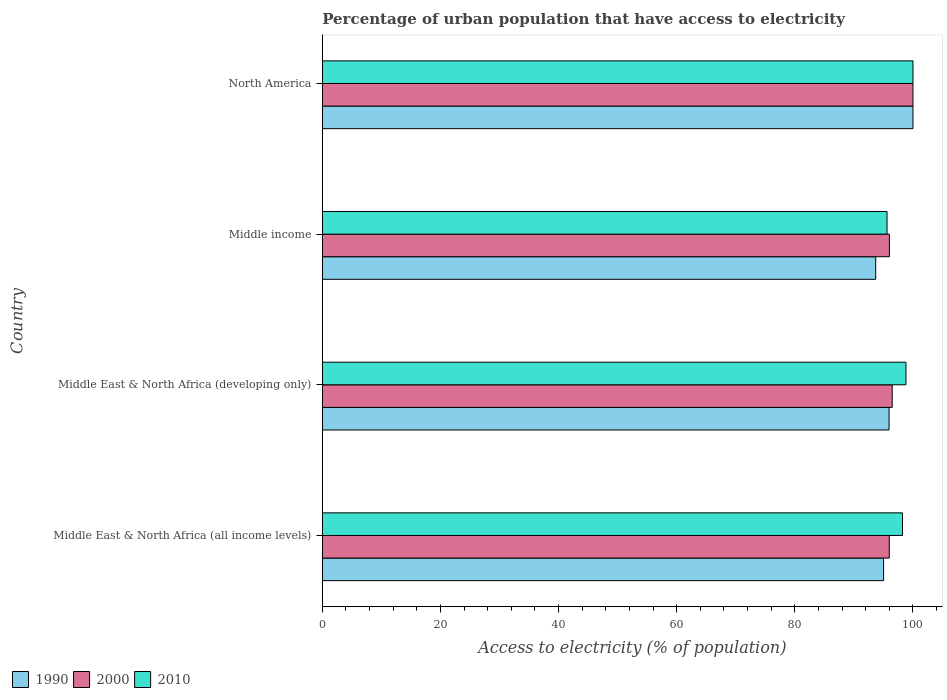How many different coloured bars are there?
Keep it short and to the point. 3. What is the label of the 3rd group of bars from the top?
Your answer should be compact. Middle East & North Africa (developing only). What is the percentage of urban population that have access to electricity in 1990 in Middle East & North Africa (developing only)?
Provide a succinct answer. 95.95. Across all countries, what is the maximum percentage of urban population that have access to electricity in 1990?
Your answer should be compact. 100. Across all countries, what is the minimum percentage of urban population that have access to electricity in 2000?
Offer a very short reply. 95.99. In which country was the percentage of urban population that have access to electricity in 2000 maximum?
Give a very brief answer. North America. In which country was the percentage of urban population that have access to electricity in 1990 minimum?
Your response must be concise. Middle income. What is the total percentage of urban population that have access to electricity in 2000 in the graph?
Provide a succinct answer. 388.48. What is the difference between the percentage of urban population that have access to electricity in 2000 in Middle East & North Africa (developing only) and that in Middle income?
Your answer should be very brief. 0.47. What is the difference between the percentage of urban population that have access to electricity in 2000 in Middle income and the percentage of urban population that have access to electricity in 2010 in Middle East & North Africa (all income levels)?
Make the answer very short. -2.22. What is the average percentage of urban population that have access to electricity in 1990 per country?
Provide a short and direct response. 96.17. What is the difference between the percentage of urban population that have access to electricity in 1990 and percentage of urban population that have access to electricity in 2010 in Middle East & North Africa (developing only)?
Your answer should be very brief. -2.86. In how many countries, is the percentage of urban population that have access to electricity in 2000 greater than 56 %?
Offer a very short reply. 4. What is the ratio of the percentage of urban population that have access to electricity in 2010 in Middle East & North Africa (developing only) to that in Middle income?
Keep it short and to the point. 1.03. Is the percentage of urban population that have access to electricity in 1990 in Middle income less than that in North America?
Your response must be concise. Yes. Is the difference between the percentage of urban population that have access to electricity in 1990 in Middle East & North Africa (all income levels) and North America greater than the difference between the percentage of urban population that have access to electricity in 2010 in Middle East & North Africa (all income levels) and North America?
Offer a terse response. No. What is the difference between the highest and the second highest percentage of urban population that have access to electricity in 1990?
Keep it short and to the point. 4.05. What is the difference between the highest and the lowest percentage of urban population that have access to electricity in 2000?
Ensure brevity in your answer.  4.01. In how many countries, is the percentage of urban population that have access to electricity in 2010 greater than the average percentage of urban population that have access to electricity in 2010 taken over all countries?
Provide a succinct answer. 3. How many bars are there?
Your answer should be compact. 12. What is the difference between two consecutive major ticks on the X-axis?
Provide a short and direct response. 20. Does the graph contain any zero values?
Your answer should be compact. No. Where does the legend appear in the graph?
Your answer should be very brief. Bottom left. What is the title of the graph?
Offer a very short reply. Percentage of urban population that have access to electricity. What is the label or title of the X-axis?
Your response must be concise. Access to electricity (% of population). What is the label or title of the Y-axis?
Make the answer very short. Country. What is the Access to electricity (% of population) in 1990 in Middle East & North Africa (all income levels)?
Offer a very short reply. 95.03. What is the Access to electricity (% of population) in 2000 in Middle East & North Africa (all income levels)?
Provide a short and direct response. 95.99. What is the Access to electricity (% of population) of 2010 in Middle East & North Africa (all income levels)?
Keep it short and to the point. 98.23. What is the Access to electricity (% of population) of 1990 in Middle East & North Africa (developing only)?
Your answer should be very brief. 95.95. What is the Access to electricity (% of population) in 2000 in Middle East & North Africa (developing only)?
Offer a terse response. 96.48. What is the Access to electricity (% of population) of 2010 in Middle East & North Africa (developing only)?
Your response must be concise. 98.82. What is the Access to electricity (% of population) in 1990 in Middle income?
Provide a succinct answer. 93.69. What is the Access to electricity (% of population) in 2000 in Middle income?
Give a very brief answer. 96.01. What is the Access to electricity (% of population) of 2010 in Middle income?
Keep it short and to the point. 95.61. What is the Access to electricity (% of population) of 1990 in North America?
Make the answer very short. 100. What is the Access to electricity (% of population) in 2000 in North America?
Provide a short and direct response. 100. Across all countries, what is the maximum Access to electricity (% of population) in 1990?
Your answer should be compact. 100. Across all countries, what is the maximum Access to electricity (% of population) of 2000?
Offer a very short reply. 100. Across all countries, what is the minimum Access to electricity (% of population) in 1990?
Your answer should be compact. 93.69. Across all countries, what is the minimum Access to electricity (% of population) of 2000?
Ensure brevity in your answer.  95.99. Across all countries, what is the minimum Access to electricity (% of population) of 2010?
Your answer should be very brief. 95.61. What is the total Access to electricity (% of population) of 1990 in the graph?
Your response must be concise. 384.67. What is the total Access to electricity (% of population) in 2000 in the graph?
Your response must be concise. 388.48. What is the total Access to electricity (% of population) in 2010 in the graph?
Your answer should be very brief. 392.65. What is the difference between the Access to electricity (% of population) in 1990 in Middle East & North Africa (all income levels) and that in Middle East & North Africa (developing only)?
Your answer should be very brief. -0.93. What is the difference between the Access to electricity (% of population) of 2000 in Middle East & North Africa (all income levels) and that in Middle East & North Africa (developing only)?
Give a very brief answer. -0.49. What is the difference between the Access to electricity (% of population) in 2010 in Middle East & North Africa (all income levels) and that in Middle East & North Africa (developing only)?
Your response must be concise. -0.59. What is the difference between the Access to electricity (% of population) in 1990 in Middle East & North Africa (all income levels) and that in Middle income?
Offer a very short reply. 1.34. What is the difference between the Access to electricity (% of population) of 2000 in Middle East & North Africa (all income levels) and that in Middle income?
Your response must be concise. -0.02. What is the difference between the Access to electricity (% of population) of 2010 in Middle East & North Africa (all income levels) and that in Middle income?
Ensure brevity in your answer.  2.62. What is the difference between the Access to electricity (% of population) of 1990 in Middle East & North Africa (all income levels) and that in North America?
Offer a very short reply. -4.97. What is the difference between the Access to electricity (% of population) of 2000 in Middle East & North Africa (all income levels) and that in North America?
Your answer should be very brief. -4.01. What is the difference between the Access to electricity (% of population) in 2010 in Middle East & North Africa (all income levels) and that in North America?
Provide a succinct answer. -1.77. What is the difference between the Access to electricity (% of population) in 1990 in Middle East & North Africa (developing only) and that in Middle income?
Provide a short and direct response. 2.26. What is the difference between the Access to electricity (% of population) in 2000 in Middle East & North Africa (developing only) and that in Middle income?
Give a very brief answer. 0.47. What is the difference between the Access to electricity (% of population) in 2010 in Middle East & North Africa (developing only) and that in Middle income?
Provide a short and direct response. 3.21. What is the difference between the Access to electricity (% of population) of 1990 in Middle East & North Africa (developing only) and that in North America?
Offer a terse response. -4.05. What is the difference between the Access to electricity (% of population) in 2000 in Middle East & North Africa (developing only) and that in North America?
Keep it short and to the point. -3.52. What is the difference between the Access to electricity (% of population) in 2010 in Middle East & North Africa (developing only) and that in North America?
Keep it short and to the point. -1.18. What is the difference between the Access to electricity (% of population) of 1990 in Middle income and that in North America?
Offer a terse response. -6.31. What is the difference between the Access to electricity (% of population) of 2000 in Middle income and that in North America?
Give a very brief answer. -3.99. What is the difference between the Access to electricity (% of population) of 2010 in Middle income and that in North America?
Provide a succinct answer. -4.39. What is the difference between the Access to electricity (% of population) in 1990 in Middle East & North Africa (all income levels) and the Access to electricity (% of population) in 2000 in Middle East & North Africa (developing only)?
Make the answer very short. -1.46. What is the difference between the Access to electricity (% of population) in 1990 in Middle East & North Africa (all income levels) and the Access to electricity (% of population) in 2010 in Middle East & North Africa (developing only)?
Your answer should be very brief. -3.79. What is the difference between the Access to electricity (% of population) in 2000 in Middle East & North Africa (all income levels) and the Access to electricity (% of population) in 2010 in Middle East & North Africa (developing only)?
Provide a succinct answer. -2.83. What is the difference between the Access to electricity (% of population) of 1990 in Middle East & North Africa (all income levels) and the Access to electricity (% of population) of 2000 in Middle income?
Your answer should be very brief. -0.98. What is the difference between the Access to electricity (% of population) of 1990 in Middle East & North Africa (all income levels) and the Access to electricity (% of population) of 2010 in Middle income?
Your answer should be compact. -0.58. What is the difference between the Access to electricity (% of population) in 2000 in Middle East & North Africa (all income levels) and the Access to electricity (% of population) in 2010 in Middle income?
Give a very brief answer. 0.38. What is the difference between the Access to electricity (% of population) in 1990 in Middle East & North Africa (all income levels) and the Access to electricity (% of population) in 2000 in North America?
Provide a succinct answer. -4.97. What is the difference between the Access to electricity (% of population) in 1990 in Middle East & North Africa (all income levels) and the Access to electricity (% of population) in 2010 in North America?
Your answer should be compact. -4.97. What is the difference between the Access to electricity (% of population) of 2000 in Middle East & North Africa (all income levels) and the Access to electricity (% of population) of 2010 in North America?
Provide a succinct answer. -4.01. What is the difference between the Access to electricity (% of population) of 1990 in Middle East & North Africa (developing only) and the Access to electricity (% of population) of 2000 in Middle income?
Your response must be concise. -0.06. What is the difference between the Access to electricity (% of population) of 1990 in Middle East & North Africa (developing only) and the Access to electricity (% of population) of 2010 in Middle income?
Make the answer very short. 0.34. What is the difference between the Access to electricity (% of population) of 2000 in Middle East & North Africa (developing only) and the Access to electricity (% of population) of 2010 in Middle income?
Your answer should be very brief. 0.87. What is the difference between the Access to electricity (% of population) of 1990 in Middle East & North Africa (developing only) and the Access to electricity (% of population) of 2000 in North America?
Keep it short and to the point. -4.05. What is the difference between the Access to electricity (% of population) in 1990 in Middle East & North Africa (developing only) and the Access to electricity (% of population) in 2010 in North America?
Your response must be concise. -4.05. What is the difference between the Access to electricity (% of population) of 2000 in Middle East & North Africa (developing only) and the Access to electricity (% of population) of 2010 in North America?
Make the answer very short. -3.52. What is the difference between the Access to electricity (% of population) in 1990 in Middle income and the Access to electricity (% of population) in 2000 in North America?
Make the answer very short. -6.31. What is the difference between the Access to electricity (% of population) of 1990 in Middle income and the Access to electricity (% of population) of 2010 in North America?
Give a very brief answer. -6.31. What is the difference between the Access to electricity (% of population) in 2000 in Middle income and the Access to electricity (% of population) in 2010 in North America?
Make the answer very short. -3.99. What is the average Access to electricity (% of population) of 1990 per country?
Keep it short and to the point. 96.17. What is the average Access to electricity (% of population) of 2000 per country?
Your answer should be compact. 97.12. What is the average Access to electricity (% of population) in 2010 per country?
Your answer should be compact. 98.16. What is the difference between the Access to electricity (% of population) of 1990 and Access to electricity (% of population) of 2000 in Middle East & North Africa (all income levels)?
Your answer should be compact. -0.96. What is the difference between the Access to electricity (% of population) of 1990 and Access to electricity (% of population) of 2010 in Middle East & North Africa (all income levels)?
Your response must be concise. -3.2. What is the difference between the Access to electricity (% of population) in 2000 and Access to electricity (% of population) in 2010 in Middle East & North Africa (all income levels)?
Make the answer very short. -2.24. What is the difference between the Access to electricity (% of population) of 1990 and Access to electricity (% of population) of 2000 in Middle East & North Africa (developing only)?
Provide a succinct answer. -0.53. What is the difference between the Access to electricity (% of population) of 1990 and Access to electricity (% of population) of 2010 in Middle East & North Africa (developing only)?
Offer a very short reply. -2.86. What is the difference between the Access to electricity (% of population) in 2000 and Access to electricity (% of population) in 2010 in Middle East & North Africa (developing only)?
Offer a very short reply. -2.33. What is the difference between the Access to electricity (% of population) of 1990 and Access to electricity (% of population) of 2000 in Middle income?
Provide a succinct answer. -2.32. What is the difference between the Access to electricity (% of population) of 1990 and Access to electricity (% of population) of 2010 in Middle income?
Offer a terse response. -1.92. What is the difference between the Access to electricity (% of population) in 2000 and Access to electricity (% of population) in 2010 in Middle income?
Provide a succinct answer. 0.4. What is the difference between the Access to electricity (% of population) in 1990 and Access to electricity (% of population) in 2010 in North America?
Make the answer very short. 0. What is the difference between the Access to electricity (% of population) in 2000 and Access to electricity (% of population) in 2010 in North America?
Provide a succinct answer. 0. What is the ratio of the Access to electricity (% of population) of 1990 in Middle East & North Africa (all income levels) to that in Middle East & North Africa (developing only)?
Offer a terse response. 0.99. What is the ratio of the Access to electricity (% of population) of 1990 in Middle East & North Africa (all income levels) to that in Middle income?
Ensure brevity in your answer.  1.01. What is the ratio of the Access to electricity (% of population) in 2000 in Middle East & North Africa (all income levels) to that in Middle income?
Keep it short and to the point. 1. What is the ratio of the Access to electricity (% of population) in 2010 in Middle East & North Africa (all income levels) to that in Middle income?
Offer a very short reply. 1.03. What is the ratio of the Access to electricity (% of population) in 1990 in Middle East & North Africa (all income levels) to that in North America?
Keep it short and to the point. 0.95. What is the ratio of the Access to electricity (% of population) of 2000 in Middle East & North Africa (all income levels) to that in North America?
Your response must be concise. 0.96. What is the ratio of the Access to electricity (% of population) of 2010 in Middle East & North Africa (all income levels) to that in North America?
Offer a terse response. 0.98. What is the ratio of the Access to electricity (% of population) in 1990 in Middle East & North Africa (developing only) to that in Middle income?
Ensure brevity in your answer.  1.02. What is the ratio of the Access to electricity (% of population) in 2000 in Middle East & North Africa (developing only) to that in Middle income?
Your response must be concise. 1. What is the ratio of the Access to electricity (% of population) of 2010 in Middle East & North Africa (developing only) to that in Middle income?
Ensure brevity in your answer.  1.03. What is the ratio of the Access to electricity (% of population) in 1990 in Middle East & North Africa (developing only) to that in North America?
Your answer should be very brief. 0.96. What is the ratio of the Access to electricity (% of population) in 2000 in Middle East & North Africa (developing only) to that in North America?
Offer a very short reply. 0.96. What is the ratio of the Access to electricity (% of population) of 1990 in Middle income to that in North America?
Offer a very short reply. 0.94. What is the ratio of the Access to electricity (% of population) of 2000 in Middle income to that in North America?
Your answer should be very brief. 0.96. What is the ratio of the Access to electricity (% of population) of 2010 in Middle income to that in North America?
Ensure brevity in your answer.  0.96. What is the difference between the highest and the second highest Access to electricity (% of population) of 1990?
Ensure brevity in your answer.  4.05. What is the difference between the highest and the second highest Access to electricity (% of population) of 2000?
Offer a very short reply. 3.52. What is the difference between the highest and the second highest Access to electricity (% of population) of 2010?
Offer a terse response. 1.18. What is the difference between the highest and the lowest Access to electricity (% of population) of 1990?
Keep it short and to the point. 6.31. What is the difference between the highest and the lowest Access to electricity (% of population) in 2000?
Make the answer very short. 4.01. What is the difference between the highest and the lowest Access to electricity (% of population) in 2010?
Provide a succinct answer. 4.39. 